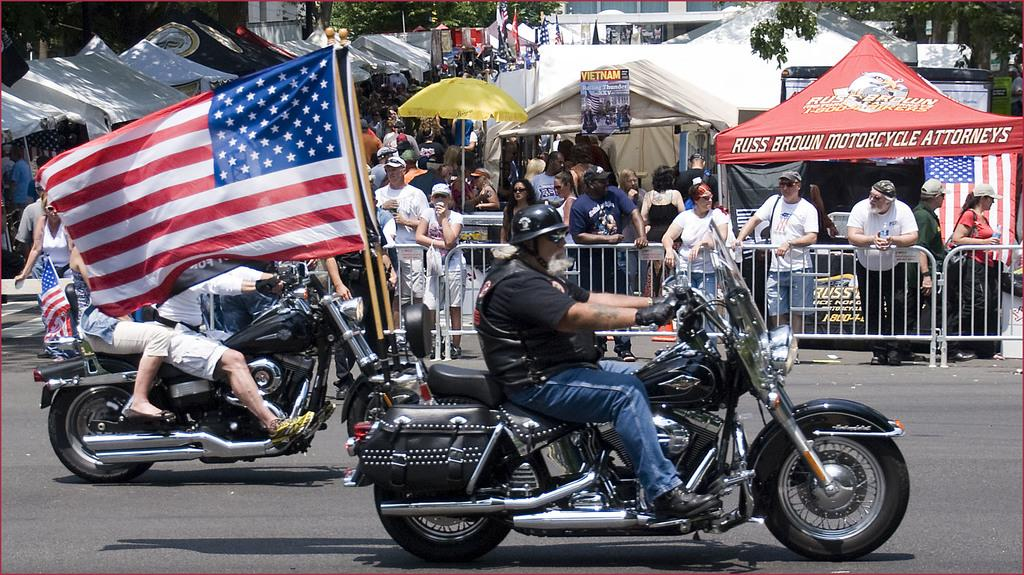Who or what can be seen in the image? There are people in the image. What are some of the people doing in the image? Some of the people are on bikes. What structures are present in the image? There are tents in the image. What additional element is present in the image? There is a flag in the image. What type of natural environment is visible in the image? There are trees in the image. What type of property is for sale in the image? There is no property for sale in the image; it features people on bikes, tents, a flag, and trees. Can you tell me where the shop is located in the image? There is no shop present in the image. 